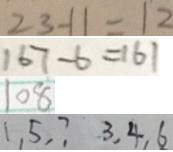Convert formula to latex. <formula><loc_0><loc_0><loc_500><loc_500>2 3 - 1 1 = 1 2 
 1 6 7 - 6 = 1 6 1 
 1 0 8 
 1 , 5 , 7 3 , 4 , 6</formula> 